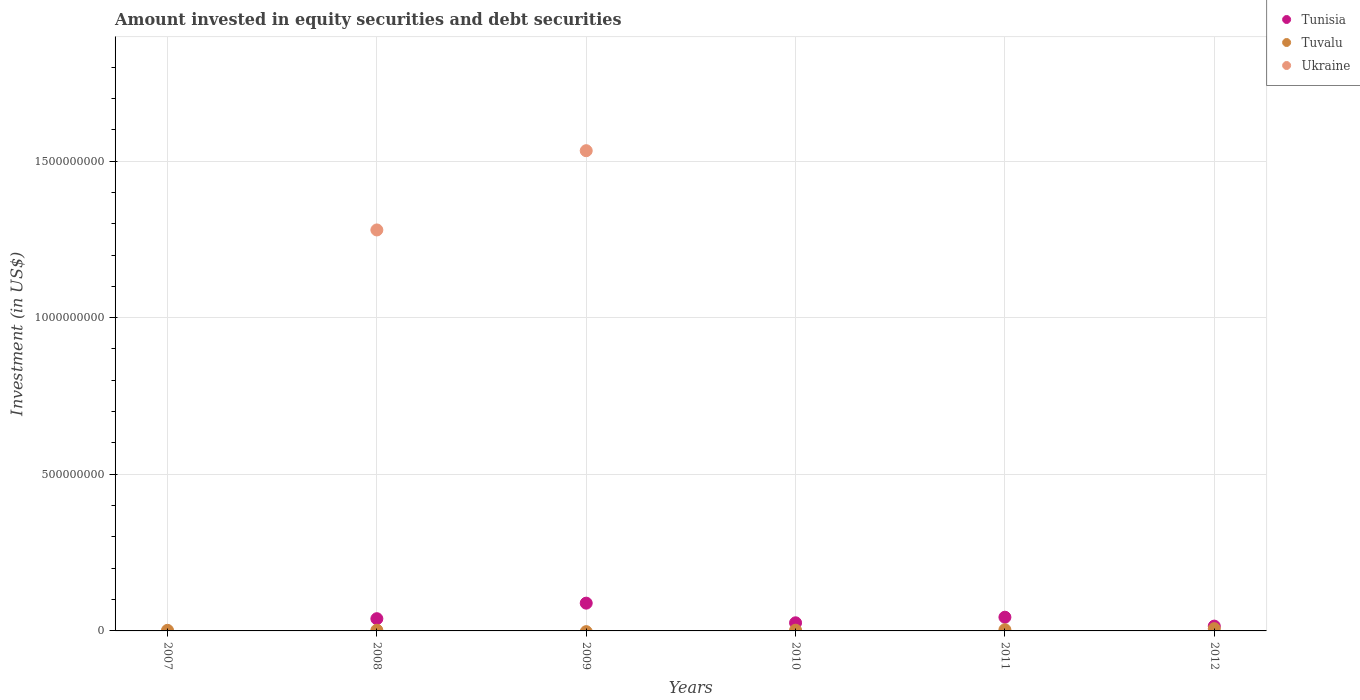How many different coloured dotlines are there?
Your response must be concise. 3. Is the number of dotlines equal to the number of legend labels?
Provide a short and direct response. No. What is the amount invested in equity securities and debt securities in Ukraine in 2010?
Provide a short and direct response. 0. Across all years, what is the maximum amount invested in equity securities and debt securities in Tunisia?
Give a very brief answer. 8.86e+07. Across all years, what is the minimum amount invested in equity securities and debt securities in Tunisia?
Your response must be concise. 0. In which year was the amount invested in equity securities and debt securities in Tuvalu maximum?
Ensure brevity in your answer.  2012. What is the total amount invested in equity securities and debt securities in Ukraine in the graph?
Provide a succinct answer. 2.81e+09. What is the difference between the amount invested in equity securities and debt securities in Tunisia in 2008 and that in 2011?
Give a very brief answer. -4.72e+06. What is the difference between the amount invested in equity securities and debt securities in Tuvalu in 2012 and the amount invested in equity securities and debt securities in Tunisia in 2010?
Offer a terse response. -1.87e+07. What is the average amount invested in equity securities and debt securities in Tunisia per year?
Ensure brevity in your answer.  3.55e+07. In the year 2010, what is the difference between the amount invested in equity securities and debt securities in Tuvalu and amount invested in equity securities and debt securities in Tunisia?
Ensure brevity in your answer.  -2.36e+07. In how many years, is the amount invested in equity securities and debt securities in Tuvalu greater than 700000000 US$?
Provide a succinct answer. 0. What is the ratio of the amount invested in equity securities and debt securities in Tuvalu in 2011 to that in 2012?
Provide a succinct answer. 0.52. Is the amount invested in equity securities and debt securities in Tunisia in 2009 less than that in 2012?
Offer a terse response. No. Is the difference between the amount invested in equity securities and debt securities in Tuvalu in 2011 and 2012 greater than the difference between the amount invested in equity securities and debt securities in Tunisia in 2011 and 2012?
Your response must be concise. No. What is the difference between the highest and the second highest amount invested in equity securities and debt securities in Tunisia?
Keep it short and to the point. 4.49e+07. What is the difference between the highest and the lowest amount invested in equity securities and debt securities in Tuvalu?
Ensure brevity in your answer.  7.24e+06. Is it the case that in every year, the sum of the amount invested in equity securities and debt securities in Tuvalu and amount invested in equity securities and debt securities in Ukraine  is greater than the amount invested in equity securities and debt securities in Tunisia?
Provide a short and direct response. No. Does the amount invested in equity securities and debt securities in Tuvalu monotonically increase over the years?
Keep it short and to the point. No. How many years are there in the graph?
Ensure brevity in your answer.  6. Where does the legend appear in the graph?
Offer a very short reply. Top right. How many legend labels are there?
Your response must be concise. 3. What is the title of the graph?
Offer a very short reply. Amount invested in equity securities and debt securities. What is the label or title of the X-axis?
Offer a very short reply. Years. What is the label or title of the Y-axis?
Your answer should be compact. Investment (in US$). What is the Investment (in US$) of Tuvalu in 2007?
Make the answer very short. 1.89e+06. What is the Investment (in US$) in Ukraine in 2007?
Offer a terse response. 0. What is the Investment (in US$) in Tunisia in 2008?
Offer a very short reply. 3.90e+07. What is the Investment (in US$) in Tuvalu in 2008?
Give a very brief answer. 2.25e+06. What is the Investment (in US$) in Ukraine in 2008?
Your answer should be very brief. 1.28e+09. What is the Investment (in US$) of Tunisia in 2009?
Keep it short and to the point. 8.86e+07. What is the Investment (in US$) in Tuvalu in 2009?
Provide a short and direct response. 0. What is the Investment (in US$) in Ukraine in 2009?
Your response must be concise. 1.53e+09. What is the Investment (in US$) in Tunisia in 2010?
Ensure brevity in your answer.  2.59e+07. What is the Investment (in US$) of Tuvalu in 2010?
Give a very brief answer. 2.31e+06. What is the Investment (in US$) in Ukraine in 2010?
Give a very brief answer. 0. What is the Investment (in US$) of Tunisia in 2011?
Your response must be concise. 4.38e+07. What is the Investment (in US$) in Tuvalu in 2011?
Ensure brevity in your answer.  3.76e+06. What is the Investment (in US$) of Ukraine in 2011?
Make the answer very short. 0. What is the Investment (in US$) of Tunisia in 2012?
Your answer should be very brief. 1.54e+07. What is the Investment (in US$) of Tuvalu in 2012?
Make the answer very short. 7.24e+06. Across all years, what is the maximum Investment (in US$) of Tunisia?
Your answer should be compact. 8.86e+07. Across all years, what is the maximum Investment (in US$) of Tuvalu?
Keep it short and to the point. 7.24e+06. Across all years, what is the maximum Investment (in US$) in Ukraine?
Make the answer very short. 1.53e+09. Across all years, what is the minimum Investment (in US$) in Tuvalu?
Make the answer very short. 0. Across all years, what is the minimum Investment (in US$) in Ukraine?
Your response must be concise. 0. What is the total Investment (in US$) of Tunisia in the graph?
Offer a terse response. 2.13e+08. What is the total Investment (in US$) in Tuvalu in the graph?
Provide a succinct answer. 1.75e+07. What is the total Investment (in US$) in Ukraine in the graph?
Offer a very short reply. 2.81e+09. What is the difference between the Investment (in US$) in Tuvalu in 2007 and that in 2008?
Your answer should be compact. -3.55e+05. What is the difference between the Investment (in US$) in Tuvalu in 2007 and that in 2010?
Make the answer very short. -4.12e+05. What is the difference between the Investment (in US$) in Tuvalu in 2007 and that in 2011?
Provide a short and direct response. -1.86e+06. What is the difference between the Investment (in US$) in Tuvalu in 2007 and that in 2012?
Offer a terse response. -5.35e+06. What is the difference between the Investment (in US$) in Tunisia in 2008 and that in 2009?
Ensure brevity in your answer.  -4.96e+07. What is the difference between the Investment (in US$) of Ukraine in 2008 and that in 2009?
Provide a succinct answer. -2.53e+08. What is the difference between the Investment (in US$) of Tunisia in 2008 and that in 2010?
Make the answer very short. 1.31e+07. What is the difference between the Investment (in US$) of Tuvalu in 2008 and that in 2010?
Your answer should be very brief. -5.76e+04. What is the difference between the Investment (in US$) in Tunisia in 2008 and that in 2011?
Your answer should be compact. -4.72e+06. What is the difference between the Investment (in US$) in Tuvalu in 2008 and that in 2011?
Offer a very short reply. -1.51e+06. What is the difference between the Investment (in US$) of Tunisia in 2008 and that in 2012?
Your response must be concise. 2.37e+07. What is the difference between the Investment (in US$) of Tuvalu in 2008 and that in 2012?
Ensure brevity in your answer.  -5.00e+06. What is the difference between the Investment (in US$) in Tunisia in 2009 and that in 2010?
Your answer should be compact. 6.27e+07. What is the difference between the Investment (in US$) of Tunisia in 2009 and that in 2011?
Your answer should be very brief. 4.49e+07. What is the difference between the Investment (in US$) of Tunisia in 2009 and that in 2012?
Provide a short and direct response. 7.33e+07. What is the difference between the Investment (in US$) of Tunisia in 2010 and that in 2011?
Ensure brevity in your answer.  -1.78e+07. What is the difference between the Investment (in US$) of Tuvalu in 2010 and that in 2011?
Give a very brief answer. -1.45e+06. What is the difference between the Investment (in US$) of Tunisia in 2010 and that in 2012?
Your response must be concise. 1.06e+07. What is the difference between the Investment (in US$) of Tuvalu in 2010 and that in 2012?
Make the answer very short. -4.94e+06. What is the difference between the Investment (in US$) of Tunisia in 2011 and that in 2012?
Your answer should be very brief. 2.84e+07. What is the difference between the Investment (in US$) in Tuvalu in 2011 and that in 2012?
Keep it short and to the point. -3.49e+06. What is the difference between the Investment (in US$) in Tuvalu in 2007 and the Investment (in US$) in Ukraine in 2008?
Provide a short and direct response. -1.28e+09. What is the difference between the Investment (in US$) in Tuvalu in 2007 and the Investment (in US$) in Ukraine in 2009?
Provide a short and direct response. -1.53e+09. What is the difference between the Investment (in US$) of Tunisia in 2008 and the Investment (in US$) of Ukraine in 2009?
Your response must be concise. -1.49e+09. What is the difference between the Investment (in US$) in Tuvalu in 2008 and the Investment (in US$) in Ukraine in 2009?
Your response must be concise. -1.53e+09. What is the difference between the Investment (in US$) in Tunisia in 2008 and the Investment (in US$) in Tuvalu in 2010?
Your answer should be very brief. 3.67e+07. What is the difference between the Investment (in US$) in Tunisia in 2008 and the Investment (in US$) in Tuvalu in 2011?
Your answer should be compact. 3.53e+07. What is the difference between the Investment (in US$) of Tunisia in 2008 and the Investment (in US$) of Tuvalu in 2012?
Ensure brevity in your answer.  3.18e+07. What is the difference between the Investment (in US$) in Tunisia in 2009 and the Investment (in US$) in Tuvalu in 2010?
Offer a terse response. 8.63e+07. What is the difference between the Investment (in US$) in Tunisia in 2009 and the Investment (in US$) in Tuvalu in 2011?
Offer a very short reply. 8.49e+07. What is the difference between the Investment (in US$) of Tunisia in 2009 and the Investment (in US$) of Tuvalu in 2012?
Make the answer very short. 8.14e+07. What is the difference between the Investment (in US$) in Tunisia in 2010 and the Investment (in US$) in Tuvalu in 2011?
Offer a terse response. 2.22e+07. What is the difference between the Investment (in US$) of Tunisia in 2010 and the Investment (in US$) of Tuvalu in 2012?
Your answer should be very brief. 1.87e+07. What is the difference between the Investment (in US$) of Tunisia in 2011 and the Investment (in US$) of Tuvalu in 2012?
Your answer should be compact. 3.65e+07. What is the average Investment (in US$) of Tunisia per year?
Your response must be concise. 3.55e+07. What is the average Investment (in US$) of Tuvalu per year?
Your answer should be very brief. 2.91e+06. What is the average Investment (in US$) in Ukraine per year?
Make the answer very short. 4.69e+08. In the year 2008, what is the difference between the Investment (in US$) of Tunisia and Investment (in US$) of Tuvalu?
Provide a short and direct response. 3.68e+07. In the year 2008, what is the difference between the Investment (in US$) of Tunisia and Investment (in US$) of Ukraine?
Make the answer very short. -1.24e+09. In the year 2008, what is the difference between the Investment (in US$) in Tuvalu and Investment (in US$) in Ukraine?
Your response must be concise. -1.28e+09. In the year 2009, what is the difference between the Investment (in US$) in Tunisia and Investment (in US$) in Ukraine?
Make the answer very short. -1.44e+09. In the year 2010, what is the difference between the Investment (in US$) in Tunisia and Investment (in US$) in Tuvalu?
Give a very brief answer. 2.36e+07. In the year 2011, what is the difference between the Investment (in US$) of Tunisia and Investment (in US$) of Tuvalu?
Provide a succinct answer. 4.00e+07. In the year 2012, what is the difference between the Investment (in US$) in Tunisia and Investment (in US$) in Tuvalu?
Ensure brevity in your answer.  8.12e+06. What is the ratio of the Investment (in US$) in Tuvalu in 2007 to that in 2008?
Your answer should be very brief. 0.84. What is the ratio of the Investment (in US$) of Tuvalu in 2007 to that in 2010?
Offer a very short reply. 0.82. What is the ratio of the Investment (in US$) of Tuvalu in 2007 to that in 2011?
Make the answer very short. 0.5. What is the ratio of the Investment (in US$) in Tuvalu in 2007 to that in 2012?
Provide a succinct answer. 0.26. What is the ratio of the Investment (in US$) of Tunisia in 2008 to that in 2009?
Ensure brevity in your answer.  0.44. What is the ratio of the Investment (in US$) in Ukraine in 2008 to that in 2009?
Your answer should be compact. 0.83. What is the ratio of the Investment (in US$) in Tunisia in 2008 to that in 2010?
Offer a very short reply. 1.51. What is the ratio of the Investment (in US$) of Tuvalu in 2008 to that in 2010?
Provide a succinct answer. 0.97. What is the ratio of the Investment (in US$) of Tunisia in 2008 to that in 2011?
Your answer should be compact. 0.89. What is the ratio of the Investment (in US$) in Tuvalu in 2008 to that in 2011?
Give a very brief answer. 0.6. What is the ratio of the Investment (in US$) of Tunisia in 2008 to that in 2012?
Your answer should be compact. 2.54. What is the ratio of the Investment (in US$) in Tuvalu in 2008 to that in 2012?
Provide a short and direct response. 0.31. What is the ratio of the Investment (in US$) of Tunisia in 2009 to that in 2010?
Offer a terse response. 3.42. What is the ratio of the Investment (in US$) in Tunisia in 2009 to that in 2011?
Your answer should be compact. 2.03. What is the ratio of the Investment (in US$) of Tunisia in 2009 to that in 2012?
Your answer should be very brief. 5.77. What is the ratio of the Investment (in US$) in Tunisia in 2010 to that in 2011?
Your answer should be very brief. 0.59. What is the ratio of the Investment (in US$) of Tuvalu in 2010 to that in 2011?
Your answer should be very brief. 0.61. What is the ratio of the Investment (in US$) of Tunisia in 2010 to that in 2012?
Your response must be concise. 1.69. What is the ratio of the Investment (in US$) of Tuvalu in 2010 to that in 2012?
Give a very brief answer. 0.32. What is the ratio of the Investment (in US$) in Tunisia in 2011 to that in 2012?
Offer a very short reply. 2.85. What is the ratio of the Investment (in US$) of Tuvalu in 2011 to that in 2012?
Keep it short and to the point. 0.52. What is the difference between the highest and the second highest Investment (in US$) in Tunisia?
Ensure brevity in your answer.  4.49e+07. What is the difference between the highest and the second highest Investment (in US$) in Tuvalu?
Your answer should be compact. 3.49e+06. What is the difference between the highest and the lowest Investment (in US$) of Tunisia?
Ensure brevity in your answer.  8.86e+07. What is the difference between the highest and the lowest Investment (in US$) of Tuvalu?
Offer a very short reply. 7.24e+06. What is the difference between the highest and the lowest Investment (in US$) of Ukraine?
Offer a terse response. 1.53e+09. 